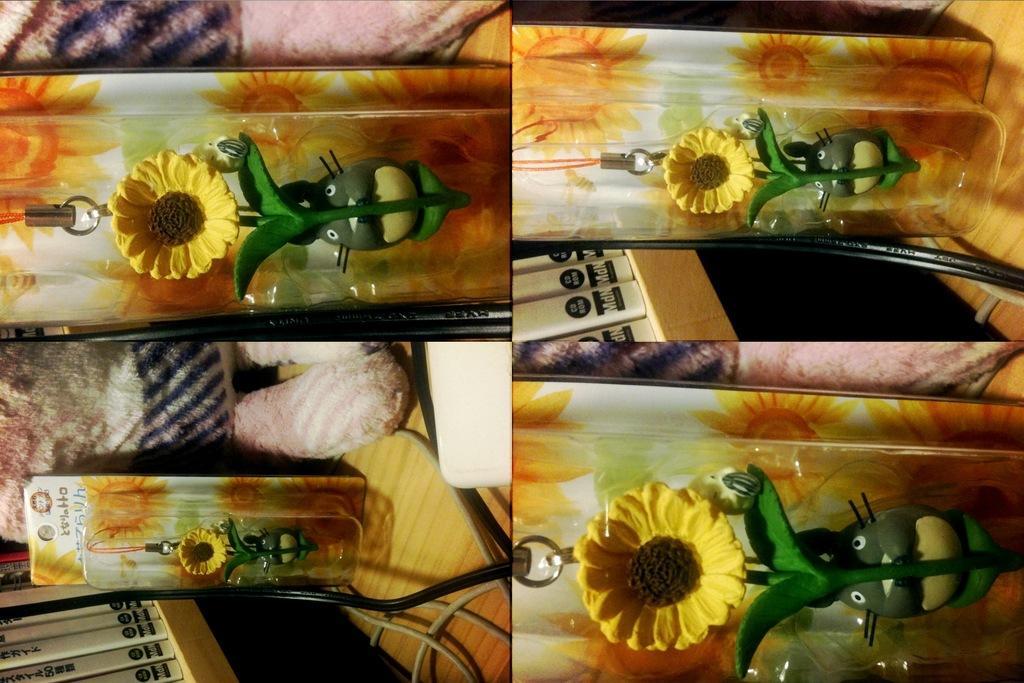Please provide a concise description of this image. In this image we can see collage of a picture in which we can see a key chain on which a flower and a doll is present. In the background we can see books in rack, cables and a doll. 